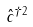Convert formula to latex. <formula><loc_0><loc_0><loc_500><loc_500>\hat { c } ^ { \dagger 2 }</formula> 